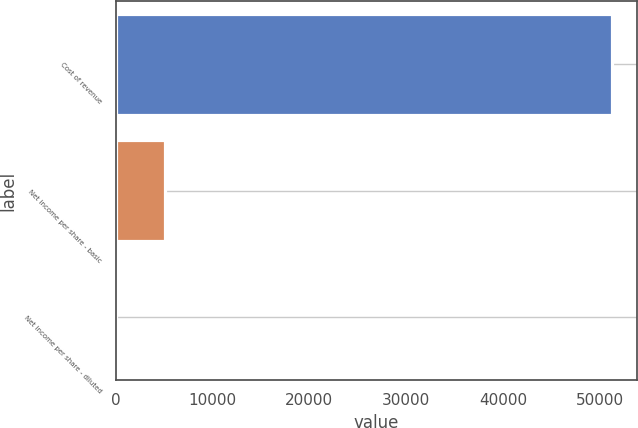<chart> <loc_0><loc_0><loc_500><loc_500><bar_chart><fcel>Cost of revenue<fcel>Net income per share - basic<fcel>Net income per share - diluted<nl><fcel>51270<fcel>5127.19<fcel>0.21<nl></chart> 